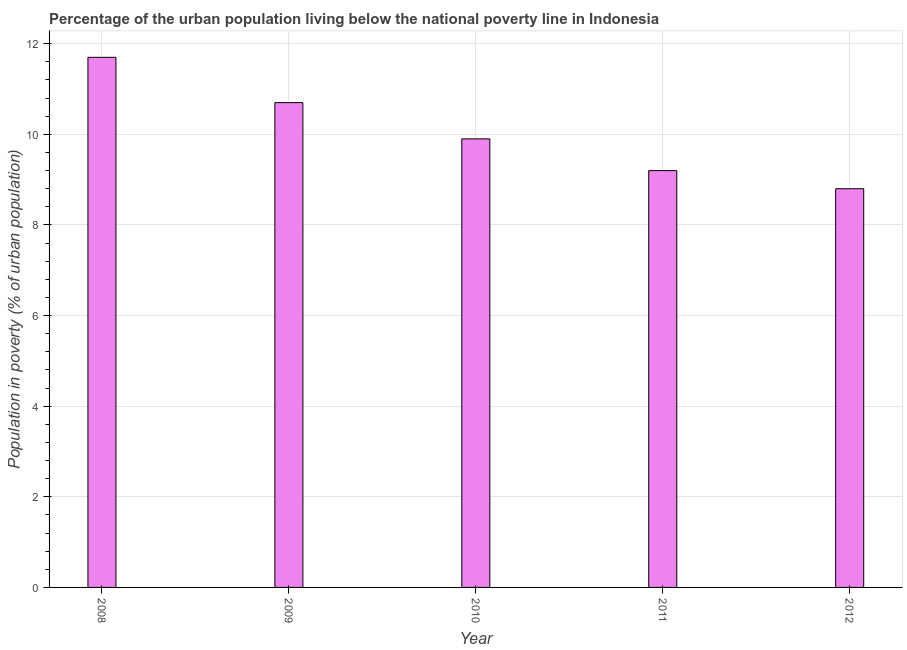Does the graph contain any zero values?
Make the answer very short. No. Does the graph contain grids?
Your answer should be compact. Yes. What is the title of the graph?
Give a very brief answer. Percentage of the urban population living below the national poverty line in Indonesia. What is the label or title of the X-axis?
Provide a succinct answer. Year. What is the label or title of the Y-axis?
Give a very brief answer. Population in poverty (% of urban population). What is the percentage of urban population living below poverty line in 2009?
Offer a terse response. 10.7. Across all years, what is the minimum percentage of urban population living below poverty line?
Provide a short and direct response. 8.8. In which year was the percentage of urban population living below poverty line minimum?
Provide a succinct answer. 2012. What is the sum of the percentage of urban population living below poverty line?
Give a very brief answer. 50.3. What is the average percentage of urban population living below poverty line per year?
Your answer should be very brief. 10.06. What is the median percentage of urban population living below poverty line?
Offer a terse response. 9.9. In how many years, is the percentage of urban population living below poverty line greater than 8.4 %?
Your answer should be very brief. 5. What is the ratio of the percentage of urban population living below poverty line in 2009 to that in 2010?
Provide a short and direct response. 1.08. How many bars are there?
Keep it short and to the point. 5. How many years are there in the graph?
Offer a terse response. 5. What is the Population in poverty (% of urban population) in 2008?
Offer a very short reply. 11.7. What is the Population in poverty (% of urban population) in 2009?
Offer a very short reply. 10.7. What is the Population in poverty (% of urban population) in 2010?
Provide a succinct answer. 9.9. What is the Population in poverty (% of urban population) in 2011?
Offer a very short reply. 9.2. What is the Population in poverty (% of urban population) in 2012?
Give a very brief answer. 8.8. What is the difference between the Population in poverty (% of urban population) in 2008 and 2011?
Give a very brief answer. 2.5. What is the difference between the Population in poverty (% of urban population) in 2008 and 2012?
Offer a terse response. 2.9. What is the difference between the Population in poverty (% of urban population) in 2009 and 2012?
Provide a short and direct response. 1.9. What is the difference between the Population in poverty (% of urban population) in 2010 and 2011?
Make the answer very short. 0.7. What is the difference between the Population in poverty (% of urban population) in 2011 and 2012?
Keep it short and to the point. 0.4. What is the ratio of the Population in poverty (% of urban population) in 2008 to that in 2009?
Your answer should be very brief. 1.09. What is the ratio of the Population in poverty (% of urban population) in 2008 to that in 2010?
Give a very brief answer. 1.18. What is the ratio of the Population in poverty (% of urban population) in 2008 to that in 2011?
Make the answer very short. 1.27. What is the ratio of the Population in poverty (% of urban population) in 2008 to that in 2012?
Make the answer very short. 1.33. What is the ratio of the Population in poverty (% of urban population) in 2009 to that in 2010?
Offer a terse response. 1.08. What is the ratio of the Population in poverty (% of urban population) in 2009 to that in 2011?
Keep it short and to the point. 1.16. What is the ratio of the Population in poverty (% of urban population) in 2009 to that in 2012?
Your response must be concise. 1.22. What is the ratio of the Population in poverty (% of urban population) in 2010 to that in 2011?
Provide a short and direct response. 1.08. What is the ratio of the Population in poverty (% of urban population) in 2010 to that in 2012?
Give a very brief answer. 1.12. What is the ratio of the Population in poverty (% of urban population) in 2011 to that in 2012?
Keep it short and to the point. 1.04. 